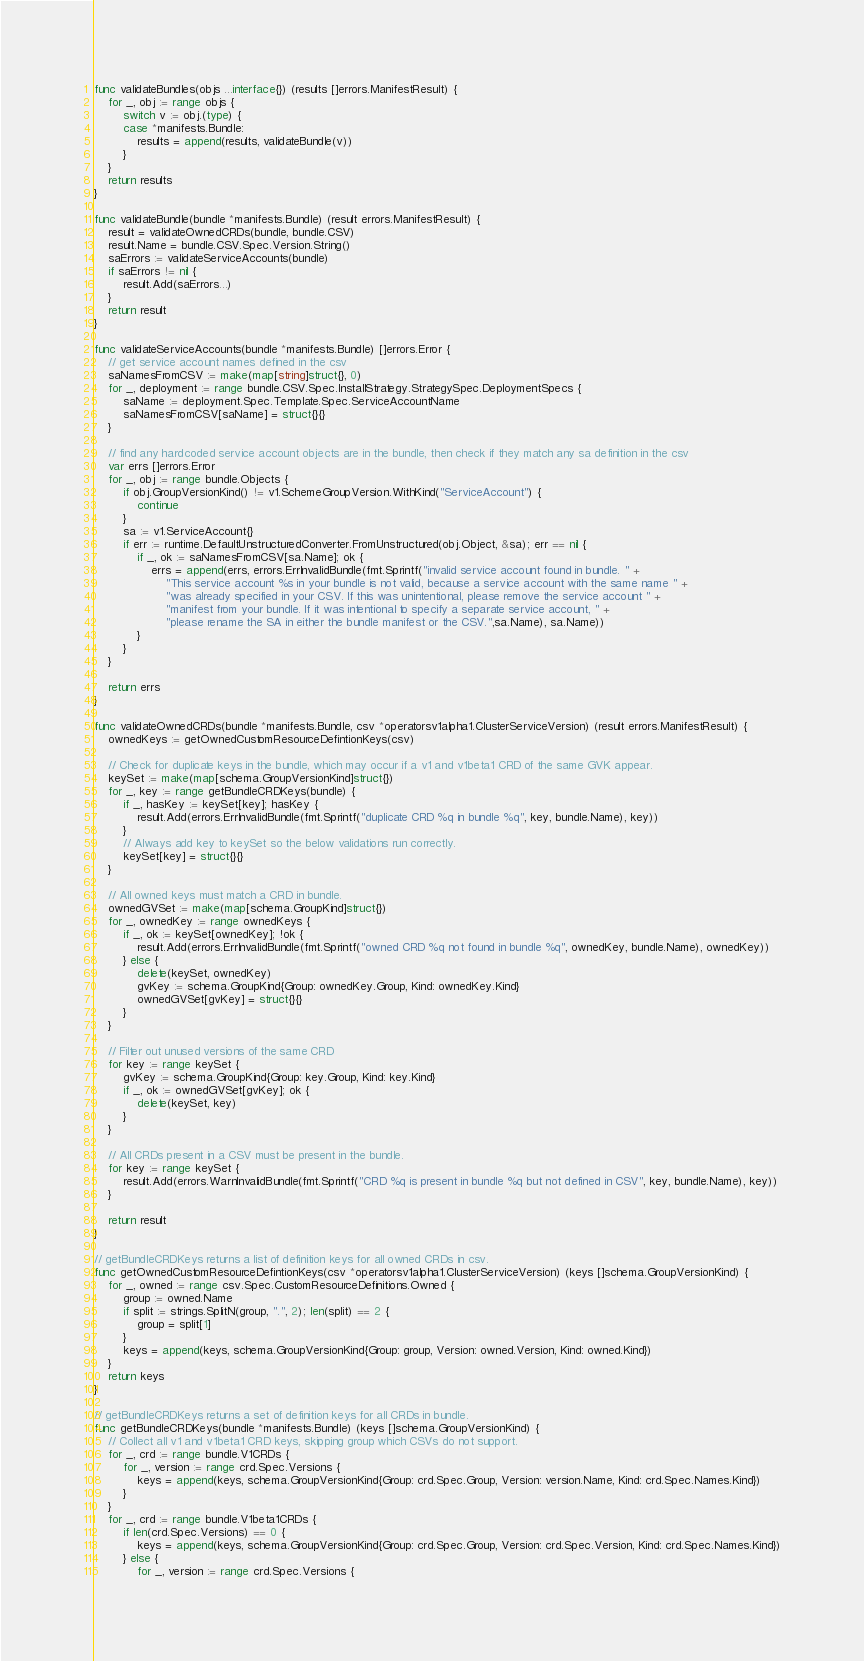Convert code to text. <code><loc_0><loc_0><loc_500><loc_500><_Go_>func validateBundles(objs ...interface{}) (results []errors.ManifestResult) {
	for _, obj := range objs {
		switch v := obj.(type) {
		case *manifests.Bundle:
			results = append(results, validateBundle(v))
		}
	}
	return results
}

func validateBundle(bundle *manifests.Bundle) (result errors.ManifestResult) {
	result = validateOwnedCRDs(bundle, bundle.CSV)
	result.Name = bundle.CSV.Spec.Version.String()
	saErrors := validateServiceAccounts(bundle)
	if saErrors != nil {
		result.Add(saErrors...)
	}
	return result
}

func validateServiceAccounts(bundle *manifests.Bundle) []errors.Error {
	// get service account names defined in the csv
	saNamesFromCSV := make(map[string]struct{}, 0)
	for _, deployment := range bundle.CSV.Spec.InstallStrategy.StrategySpec.DeploymentSpecs {
		saName := deployment.Spec.Template.Spec.ServiceAccountName
		saNamesFromCSV[saName] = struct{}{}
	}

	// find any hardcoded service account objects are in the bundle, then check if they match any sa definition in the csv
	var errs []errors.Error
	for _, obj := range bundle.Objects {
		if obj.GroupVersionKind() != v1.SchemeGroupVersion.WithKind("ServiceAccount") {
			continue
		}
		sa := v1.ServiceAccount{}
		if err := runtime.DefaultUnstructuredConverter.FromUnstructured(obj.Object, &sa); err == nil {
			if _, ok := saNamesFromCSV[sa.Name]; ok {
				errs = append(errs, errors.ErrInvalidBundle(fmt.Sprintf("invalid service account found in bundle. " +
					"This service account %s in your bundle is not valid, because a service account with the same name " +
					"was already specified in your CSV. If this was unintentional, please remove the service account " +
					"manifest from your bundle. If it was intentional to specify a separate service account, " +
					"please rename the SA in either the bundle manifest or the CSV.",sa.Name), sa.Name))
			}
		}
	}

	return errs
}

func validateOwnedCRDs(bundle *manifests.Bundle, csv *operatorsv1alpha1.ClusterServiceVersion) (result errors.ManifestResult) {
	ownedKeys := getOwnedCustomResourceDefintionKeys(csv)

	// Check for duplicate keys in the bundle, which may occur if a v1 and v1beta1 CRD of the same GVK appear.
	keySet := make(map[schema.GroupVersionKind]struct{})
	for _, key := range getBundleCRDKeys(bundle) {
		if _, hasKey := keySet[key]; hasKey {
			result.Add(errors.ErrInvalidBundle(fmt.Sprintf("duplicate CRD %q in bundle %q", key, bundle.Name), key))
		}
		// Always add key to keySet so the below validations run correctly.
		keySet[key] = struct{}{}
	}

	// All owned keys must match a CRD in bundle.
	ownedGVSet := make(map[schema.GroupKind]struct{})
	for _, ownedKey := range ownedKeys {
		if _, ok := keySet[ownedKey]; !ok {
			result.Add(errors.ErrInvalidBundle(fmt.Sprintf("owned CRD %q not found in bundle %q", ownedKey, bundle.Name), ownedKey))
		} else {
			delete(keySet, ownedKey)
			gvKey := schema.GroupKind{Group: ownedKey.Group, Kind: ownedKey.Kind}
			ownedGVSet[gvKey] = struct{}{}
		}
	}

	// Filter out unused versions of the same CRD
	for key := range keySet {
		gvKey := schema.GroupKind{Group: key.Group, Kind: key.Kind}
		if _, ok := ownedGVSet[gvKey]; ok {
			delete(keySet, key)
		}
	}

	// All CRDs present in a CSV must be present in the bundle.
	for key := range keySet {
		result.Add(errors.WarnInvalidBundle(fmt.Sprintf("CRD %q is present in bundle %q but not defined in CSV", key, bundle.Name), key))
	}

	return result
}

// getBundleCRDKeys returns a list of definition keys for all owned CRDs in csv.
func getOwnedCustomResourceDefintionKeys(csv *operatorsv1alpha1.ClusterServiceVersion) (keys []schema.GroupVersionKind) {
	for _, owned := range csv.Spec.CustomResourceDefinitions.Owned {
		group := owned.Name
		if split := strings.SplitN(group, ".", 2); len(split) == 2 {
			group = split[1]
		}
		keys = append(keys, schema.GroupVersionKind{Group: group, Version: owned.Version, Kind: owned.Kind})
	}
	return keys
}

// getBundleCRDKeys returns a set of definition keys for all CRDs in bundle.
func getBundleCRDKeys(bundle *manifests.Bundle) (keys []schema.GroupVersionKind) {
	// Collect all v1 and v1beta1 CRD keys, skipping group which CSVs do not support.
	for _, crd := range bundle.V1CRDs {
		for _, version := range crd.Spec.Versions {
			keys = append(keys, schema.GroupVersionKind{Group: crd.Spec.Group, Version: version.Name, Kind: crd.Spec.Names.Kind})
		}
	}
	for _, crd := range bundle.V1beta1CRDs {
		if len(crd.Spec.Versions) == 0 {
			keys = append(keys, schema.GroupVersionKind{Group: crd.Spec.Group, Version: crd.Spec.Version, Kind: crd.Spec.Names.Kind})
		} else {
			for _, version := range crd.Spec.Versions {</code> 